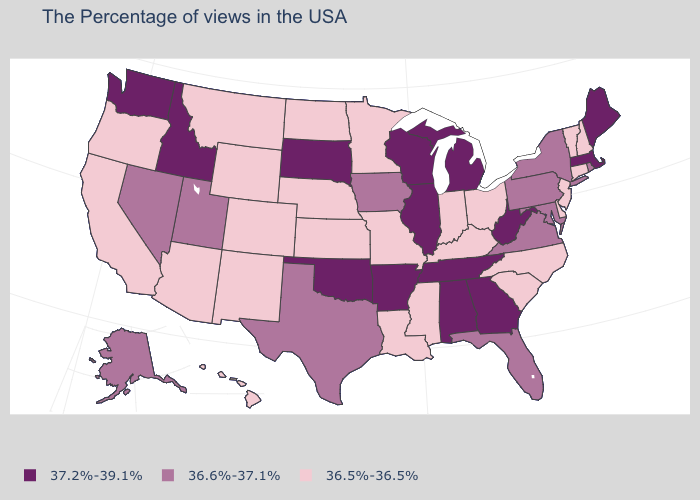Does Nevada have the lowest value in the USA?
Write a very short answer. No. Name the states that have a value in the range 36.5%-36.5%?
Quick response, please. New Hampshire, Vermont, Connecticut, New Jersey, Delaware, North Carolina, South Carolina, Ohio, Kentucky, Indiana, Mississippi, Louisiana, Missouri, Minnesota, Kansas, Nebraska, North Dakota, Wyoming, Colorado, New Mexico, Montana, Arizona, California, Oregon, Hawaii. Name the states that have a value in the range 36.5%-36.5%?
Give a very brief answer. New Hampshire, Vermont, Connecticut, New Jersey, Delaware, North Carolina, South Carolina, Ohio, Kentucky, Indiana, Mississippi, Louisiana, Missouri, Minnesota, Kansas, Nebraska, North Dakota, Wyoming, Colorado, New Mexico, Montana, Arizona, California, Oregon, Hawaii. What is the value of Rhode Island?
Answer briefly. 36.6%-37.1%. Does the first symbol in the legend represent the smallest category?
Concise answer only. No. Does Alabama have the highest value in the USA?
Write a very short answer. Yes. What is the value of South Carolina?
Concise answer only. 36.5%-36.5%. Is the legend a continuous bar?
Answer briefly. No. Does Wyoming have the highest value in the USA?
Short answer required. No. Does the map have missing data?
Write a very short answer. No. What is the lowest value in the USA?
Concise answer only. 36.5%-36.5%. Does Nevada have the lowest value in the USA?
Give a very brief answer. No. What is the value of Connecticut?
Answer briefly. 36.5%-36.5%. What is the highest value in the MidWest ?
Answer briefly. 37.2%-39.1%. Does Tennessee have the same value as Kansas?
Quick response, please. No. 